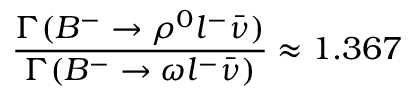Convert formula to latex. <formula><loc_0><loc_0><loc_500><loc_500>\frac { \Gamma ( B ^ { - } \rightarrow \rho ^ { 0 } l ^ { - } \bar { \nu } ) } { \Gamma ( B ^ { - } \rightarrow \omega l ^ { - } \bar { \nu } ) } \approx 1 . 3 6 7</formula> 